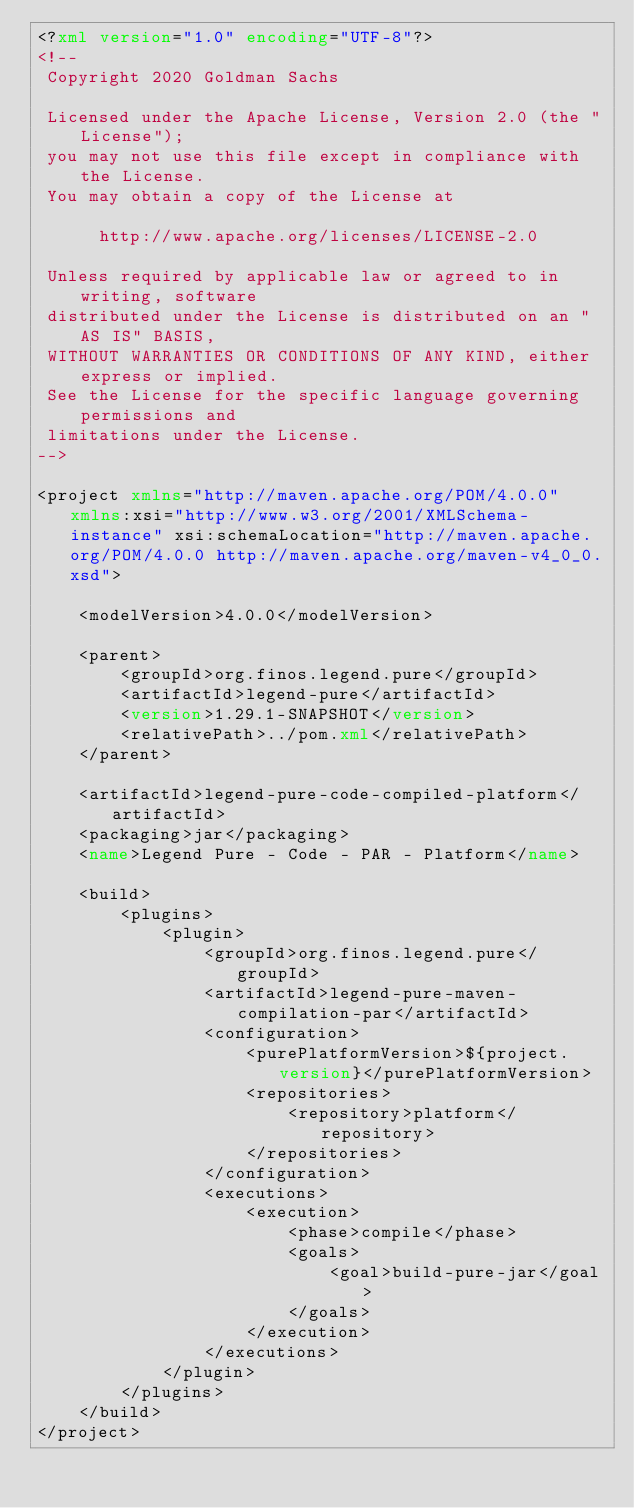<code> <loc_0><loc_0><loc_500><loc_500><_XML_><?xml version="1.0" encoding="UTF-8"?>
<!--
 Copyright 2020 Goldman Sachs

 Licensed under the Apache License, Version 2.0 (the "License");
 you may not use this file except in compliance with the License.
 You may obtain a copy of the License at

      http://www.apache.org/licenses/LICENSE-2.0

 Unless required by applicable law or agreed to in writing, software
 distributed under the License is distributed on an "AS IS" BASIS,
 WITHOUT WARRANTIES OR CONDITIONS OF ANY KIND, either express or implied.
 See the License for the specific language governing permissions and
 limitations under the License.
-->

<project xmlns="http://maven.apache.org/POM/4.0.0" xmlns:xsi="http://www.w3.org/2001/XMLSchema-instance" xsi:schemaLocation="http://maven.apache.org/POM/4.0.0 http://maven.apache.org/maven-v4_0_0.xsd">

    <modelVersion>4.0.0</modelVersion>

    <parent>
        <groupId>org.finos.legend.pure</groupId>
        <artifactId>legend-pure</artifactId>
        <version>1.29.1-SNAPSHOT</version>
        <relativePath>../pom.xml</relativePath>
    </parent>

    <artifactId>legend-pure-code-compiled-platform</artifactId>
    <packaging>jar</packaging>
    <name>Legend Pure - Code - PAR - Platform</name>

    <build>
        <plugins>
            <plugin>
                <groupId>org.finos.legend.pure</groupId>
                <artifactId>legend-pure-maven-compilation-par</artifactId>
                <configuration>
                    <purePlatformVersion>${project.version}</purePlatformVersion>
                    <repositories>
                        <repository>platform</repository>
                    </repositories>
                </configuration>
                <executions>
                    <execution>
                        <phase>compile</phase>
                        <goals>
                            <goal>build-pure-jar</goal>
                        </goals>
                    </execution>
                </executions>
            </plugin>
        </plugins>
    </build>
</project>
</code> 